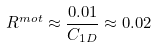Convert formula to latex. <formula><loc_0><loc_0><loc_500><loc_500>R ^ { m o t } \approx \frac { 0 . 0 1 } { C _ { 1 D } } \approx 0 . 0 2</formula> 